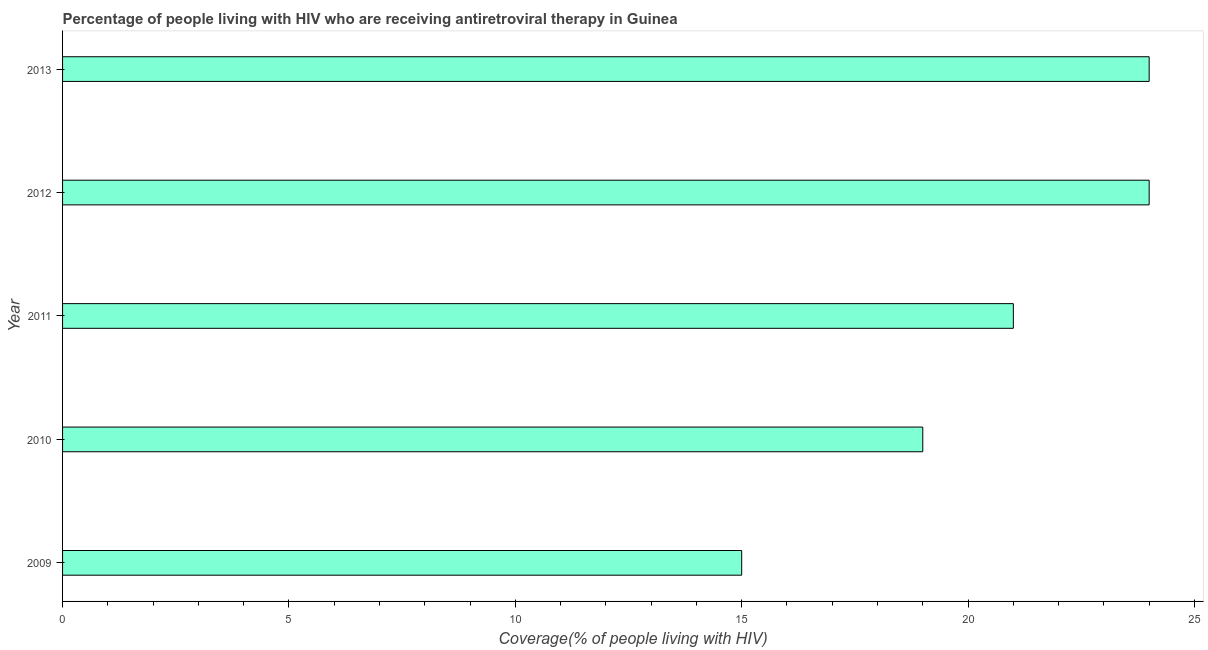Does the graph contain any zero values?
Ensure brevity in your answer.  No. Does the graph contain grids?
Your answer should be very brief. No. What is the title of the graph?
Provide a short and direct response. Percentage of people living with HIV who are receiving antiretroviral therapy in Guinea. What is the label or title of the X-axis?
Provide a succinct answer. Coverage(% of people living with HIV). What is the antiretroviral therapy coverage in 2010?
Keep it short and to the point. 19. Across all years, what is the maximum antiretroviral therapy coverage?
Your answer should be very brief. 24. Across all years, what is the minimum antiretroviral therapy coverage?
Give a very brief answer. 15. In which year was the antiretroviral therapy coverage minimum?
Provide a short and direct response. 2009. What is the sum of the antiretroviral therapy coverage?
Provide a succinct answer. 103. What is the average antiretroviral therapy coverage per year?
Keep it short and to the point. 20. What is the median antiretroviral therapy coverage?
Offer a very short reply. 21. In how many years, is the antiretroviral therapy coverage greater than 13 %?
Give a very brief answer. 5. What is the ratio of the antiretroviral therapy coverage in 2009 to that in 2010?
Your response must be concise. 0.79. What is the difference between the highest and the second highest antiretroviral therapy coverage?
Ensure brevity in your answer.  0. Is the sum of the antiretroviral therapy coverage in 2011 and 2013 greater than the maximum antiretroviral therapy coverage across all years?
Your answer should be very brief. Yes. In how many years, is the antiretroviral therapy coverage greater than the average antiretroviral therapy coverage taken over all years?
Offer a terse response. 3. What is the Coverage(% of people living with HIV) of 2009?
Provide a succinct answer. 15. What is the Coverage(% of people living with HIV) of 2011?
Keep it short and to the point. 21. What is the Coverage(% of people living with HIV) in 2012?
Offer a terse response. 24. What is the Coverage(% of people living with HIV) in 2013?
Make the answer very short. 24. What is the difference between the Coverage(% of people living with HIV) in 2009 and 2010?
Your answer should be compact. -4. What is the difference between the Coverage(% of people living with HIV) in 2009 and 2011?
Offer a terse response. -6. What is the difference between the Coverage(% of people living with HIV) in 2009 and 2012?
Provide a succinct answer. -9. What is the difference between the Coverage(% of people living with HIV) in 2009 and 2013?
Ensure brevity in your answer.  -9. What is the difference between the Coverage(% of people living with HIV) in 2010 and 2013?
Your answer should be compact. -5. What is the difference between the Coverage(% of people living with HIV) in 2012 and 2013?
Your answer should be compact. 0. What is the ratio of the Coverage(% of people living with HIV) in 2009 to that in 2010?
Offer a very short reply. 0.79. What is the ratio of the Coverage(% of people living with HIV) in 2009 to that in 2011?
Provide a succinct answer. 0.71. What is the ratio of the Coverage(% of people living with HIV) in 2010 to that in 2011?
Offer a terse response. 0.91. What is the ratio of the Coverage(% of people living with HIV) in 2010 to that in 2012?
Your answer should be very brief. 0.79. What is the ratio of the Coverage(% of people living with HIV) in 2010 to that in 2013?
Offer a terse response. 0.79. What is the ratio of the Coverage(% of people living with HIV) in 2011 to that in 2012?
Provide a short and direct response. 0.88. What is the ratio of the Coverage(% of people living with HIV) in 2011 to that in 2013?
Make the answer very short. 0.88. 